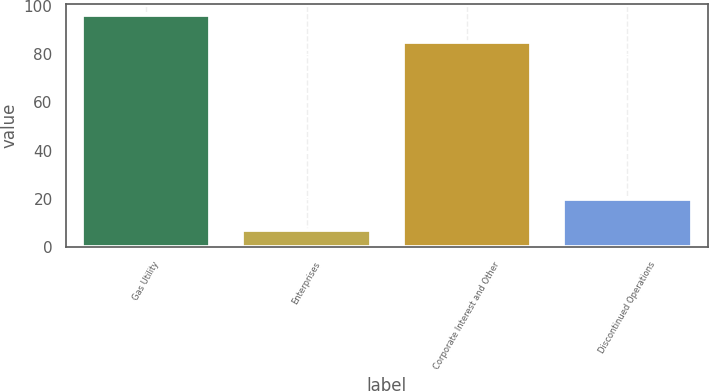Convert chart. <chart><loc_0><loc_0><loc_500><loc_500><bar_chart><fcel>Gas Utility<fcel>Enterprises<fcel>Corporate Interest and Other<fcel>Discontinued Operations<nl><fcel>96<fcel>7<fcel>85<fcel>20<nl></chart> 